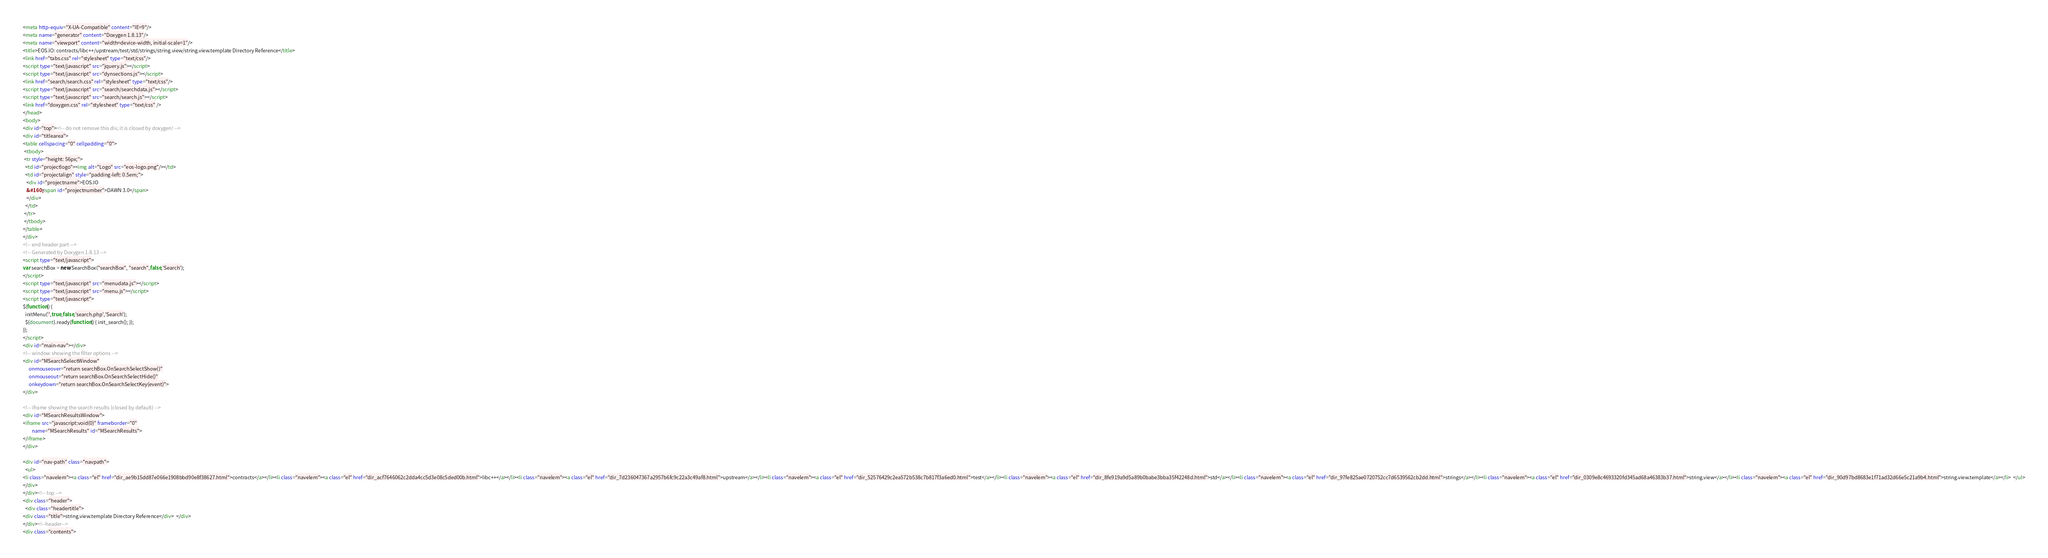<code> <loc_0><loc_0><loc_500><loc_500><_HTML_><meta http-equiv="X-UA-Compatible" content="IE=9"/>
<meta name="generator" content="Doxygen 1.8.13"/>
<meta name="viewport" content="width=device-width, initial-scale=1"/>
<title>EOS.IO: contracts/libc++/upstream/test/std/strings/string.view/string.view.template Directory Reference</title>
<link href="tabs.css" rel="stylesheet" type="text/css"/>
<script type="text/javascript" src="jquery.js"></script>
<script type="text/javascript" src="dynsections.js"></script>
<link href="search/search.css" rel="stylesheet" type="text/css"/>
<script type="text/javascript" src="search/searchdata.js"></script>
<script type="text/javascript" src="search/search.js"></script>
<link href="doxygen.css" rel="stylesheet" type="text/css" />
</head>
<body>
<div id="top"><!-- do not remove this div, it is closed by doxygen! -->
<div id="titlearea">
<table cellspacing="0" cellpadding="0">
 <tbody>
 <tr style="height: 56px;">
  <td id="projectlogo"><img alt="Logo" src="eos-logo.png"/></td>
  <td id="projectalign" style="padding-left: 0.5em;">
   <div id="projectname">EOS.IO
   &#160;<span id="projectnumber">DAWN 3.0</span>
   </div>
  </td>
 </tr>
 </tbody>
</table>
</div>
<!-- end header part -->
<!-- Generated by Doxygen 1.8.13 -->
<script type="text/javascript">
var searchBox = new SearchBox("searchBox", "search",false,'Search');
</script>
<script type="text/javascript" src="menudata.js"></script>
<script type="text/javascript" src="menu.js"></script>
<script type="text/javascript">
$(function() {
  initMenu('',true,false,'search.php','Search');
  $(document).ready(function() { init_search(); });
});
</script>
<div id="main-nav"></div>
<!-- window showing the filter options -->
<div id="MSearchSelectWindow"
     onmouseover="return searchBox.OnSearchSelectShow()"
     onmouseout="return searchBox.OnSearchSelectHide()"
     onkeydown="return searchBox.OnSearchSelectKey(event)">
</div>

<!-- iframe showing the search results (closed by default) -->
<div id="MSearchResultsWindow">
<iframe src="javascript:void(0)" frameborder="0" 
        name="MSearchResults" id="MSearchResults">
</iframe>
</div>

<div id="nav-path" class="navpath">
  <ul>
<li class="navelem"><a class="el" href="dir_ae9b15dd87e066e1908bbd90e8f38627.html">contracts</a></li><li class="navelem"><a class="el" href="dir_acf7646062c2dda4cc5d3e08c5ded00b.html">libc++</a></li><li class="navelem"><a class="el" href="dir_7d236047367a2957b6fc9c22a3c49af8.html">upstream</a></li><li class="navelem"><a class="el" href="dir_52576429c2ea572b538c7b817f3a6ed0.html">test</a></li><li class="navelem"><a class="el" href="dir_8fe919a9d5a89b0babe3bba35f42248d.html">std</a></li><li class="navelem"><a class="el" href="dir_97fe825ae0720752cc7d6539562cb2dd.html">strings</a></li><li class="navelem"><a class="el" href="dir_0309e8c4693320fd345ad68a46383b37.html">string.view</a></li><li class="navelem"><a class="el" href="dir_90d97bd8683e1f71ad32d66e5c21a9b4.html">string.view.template</a></li>  </ul>
</div>
</div><!-- top -->
<div class="header">
  <div class="headertitle">
<div class="title">string.view.template Directory Reference</div>  </div>
</div><!--header-->
<div class="contents"></code> 